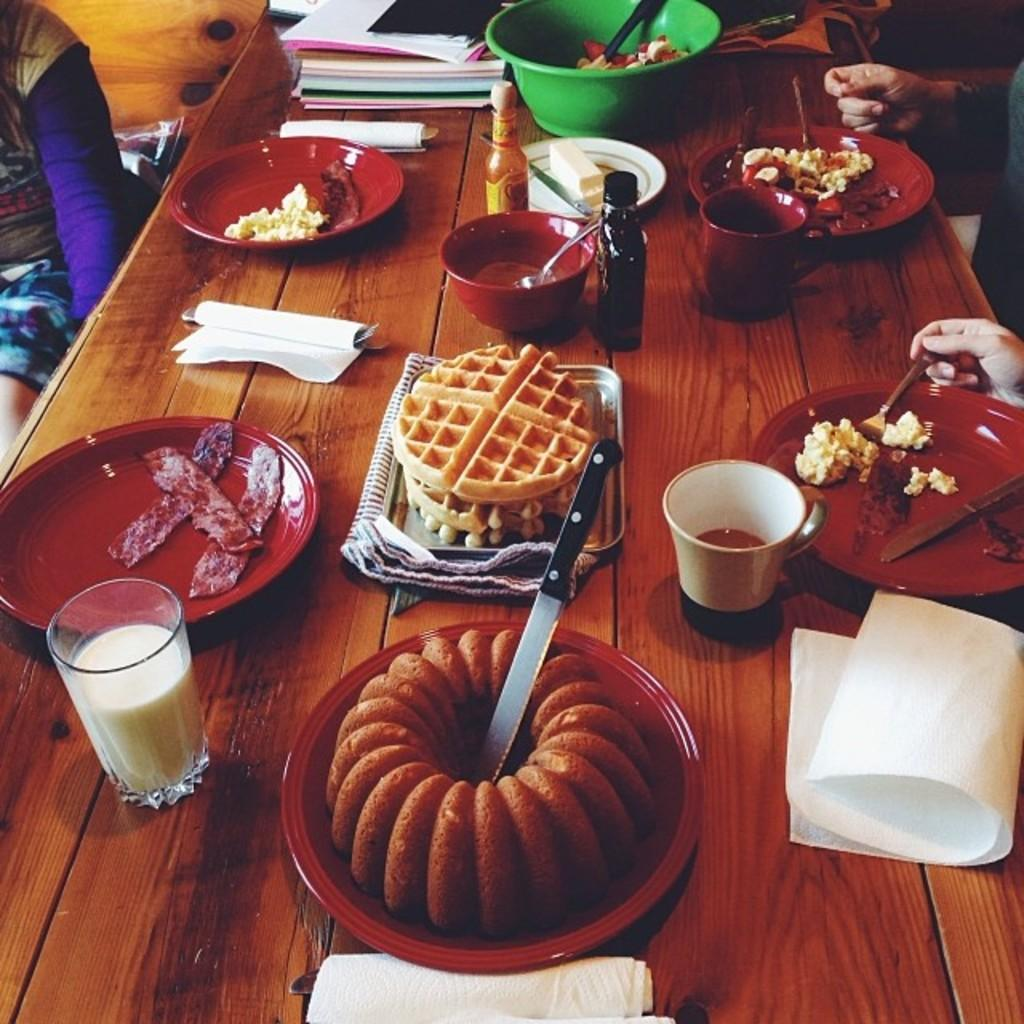What type of table is in the image? There is a wooden table in the image. What is on the table? There is a glass of milk, a plate, and a bowl on the table. What might be used for drinking in the image? The glass of milk on the table might be used for drinking. What might be used for holding food in the image? The plate and bowl on the table might be used for holding food. Can you see any steam coming from the glass of milk in the image? There is no steam visible in the image; it is a still image. 